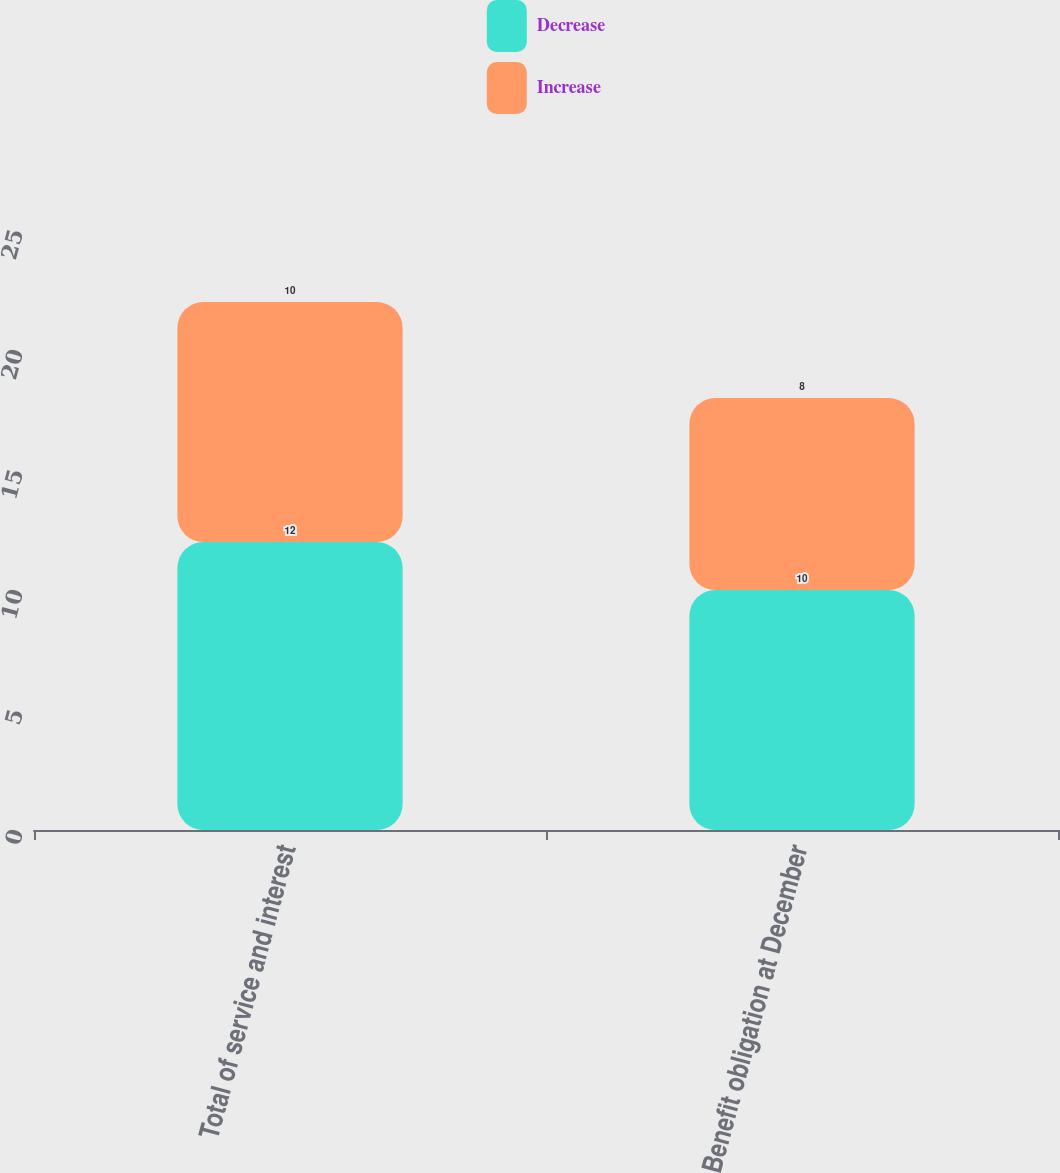Convert chart. <chart><loc_0><loc_0><loc_500><loc_500><stacked_bar_chart><ecel><fcel>Total of service and interest<fcel>Benefit obligation at December<nl><fcel>Decrease<fcel>12<fcel>10<nl><fcel>Increase<fcel>10<fcel>8<nl></chart> 